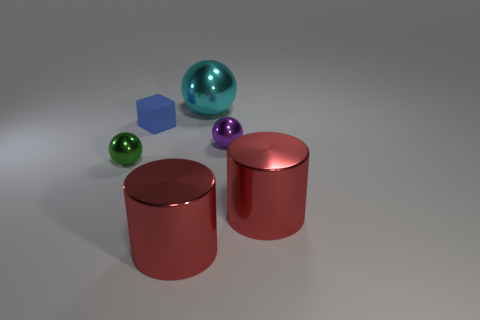Subtract all tiny balls. How many balls are left? 1 Add 3 green metal balls. How many objects exist? 9 Subtract all purple spheres. How many spheres are left? 2 Subtract all blocks. How many objects are left? 5 Add 3 green metallic things. How many green metallic things are left? 4 Add 5 big brown metal spheres. How many big brown metal spheres exist? 5 Subtract 0 purple cylinders. How many objects are left? 6 Subtract all cyan cubes. Subtract all yellow spheres. How many cubes are left? 1 Subtract all big cylinders. Subtract all blue rubber things. How many objects are left? 3 